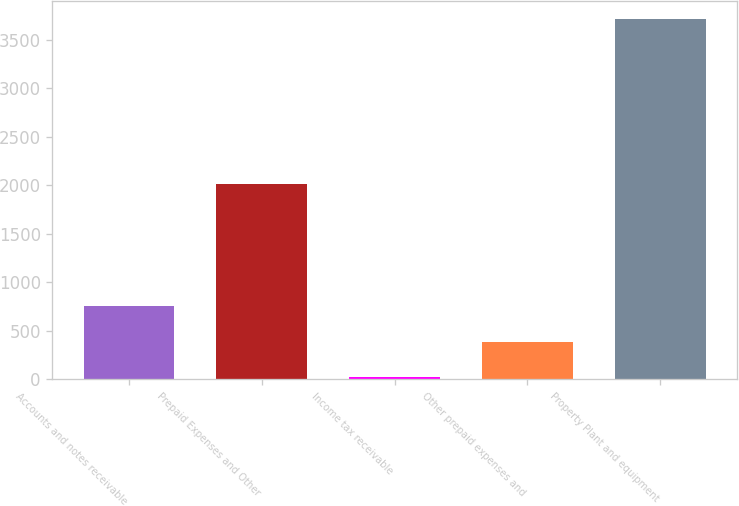Convert chart. <chart><loc_0><loc_0><loc_500><loc_500><bar_chart><fcel>Accounts and notes receivable<fcel>Prepaid Expenses and Other<fcel>Income tax receivable<fcel>Other prepaid expenses and<fcel>Property Plant and equipment<nl><fcel>758<fcel>2008<fcel>20<fcel>389<fcel>3710<nl></chart> 